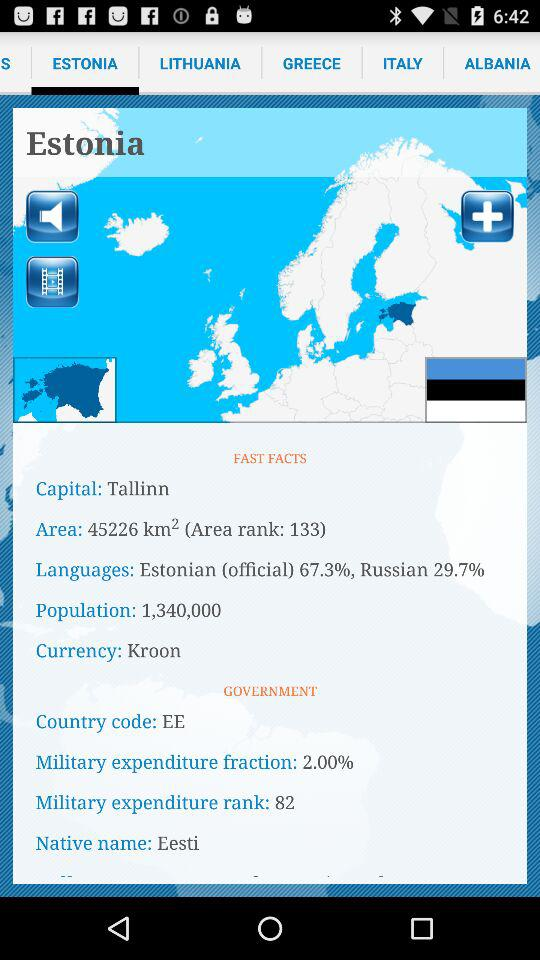What is the population of Estonia?
Answer the question using a single word or phrase. 1,340,000 